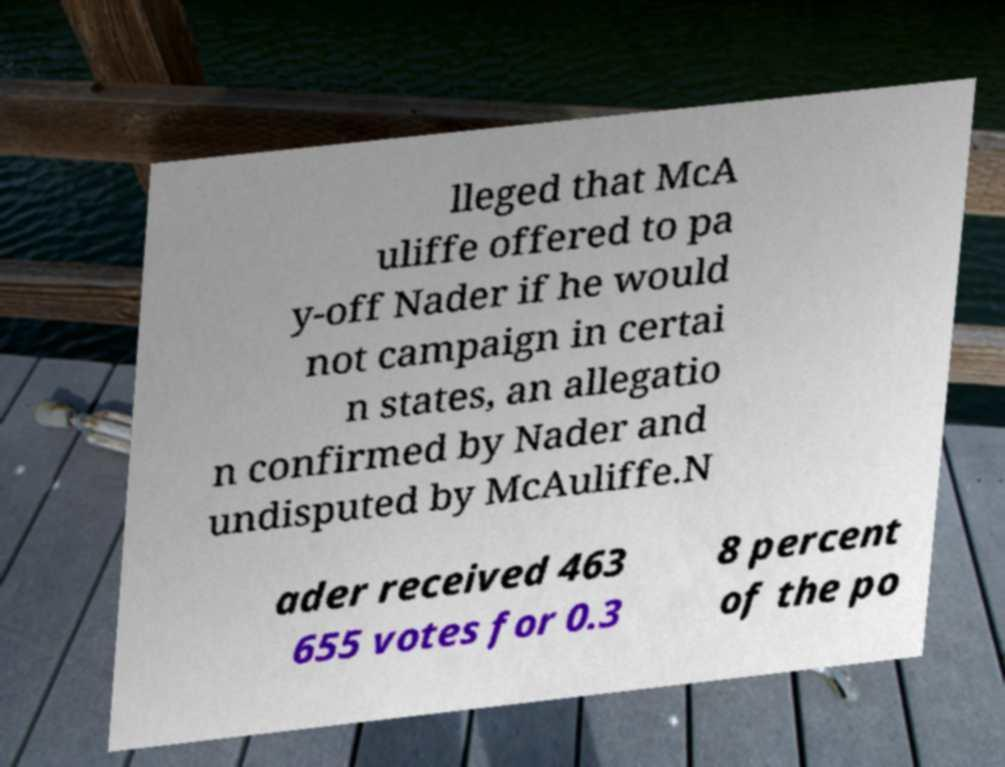Could you extract and type out the text from this image? lleged that McA uliffe offered to pa y-off Nader if he would not campaign in certai n states, an allegatio n confirmed by Nader and undisputed by McAuliffe.N ader received 463 655 votes for 0.3 8 percent of the po 